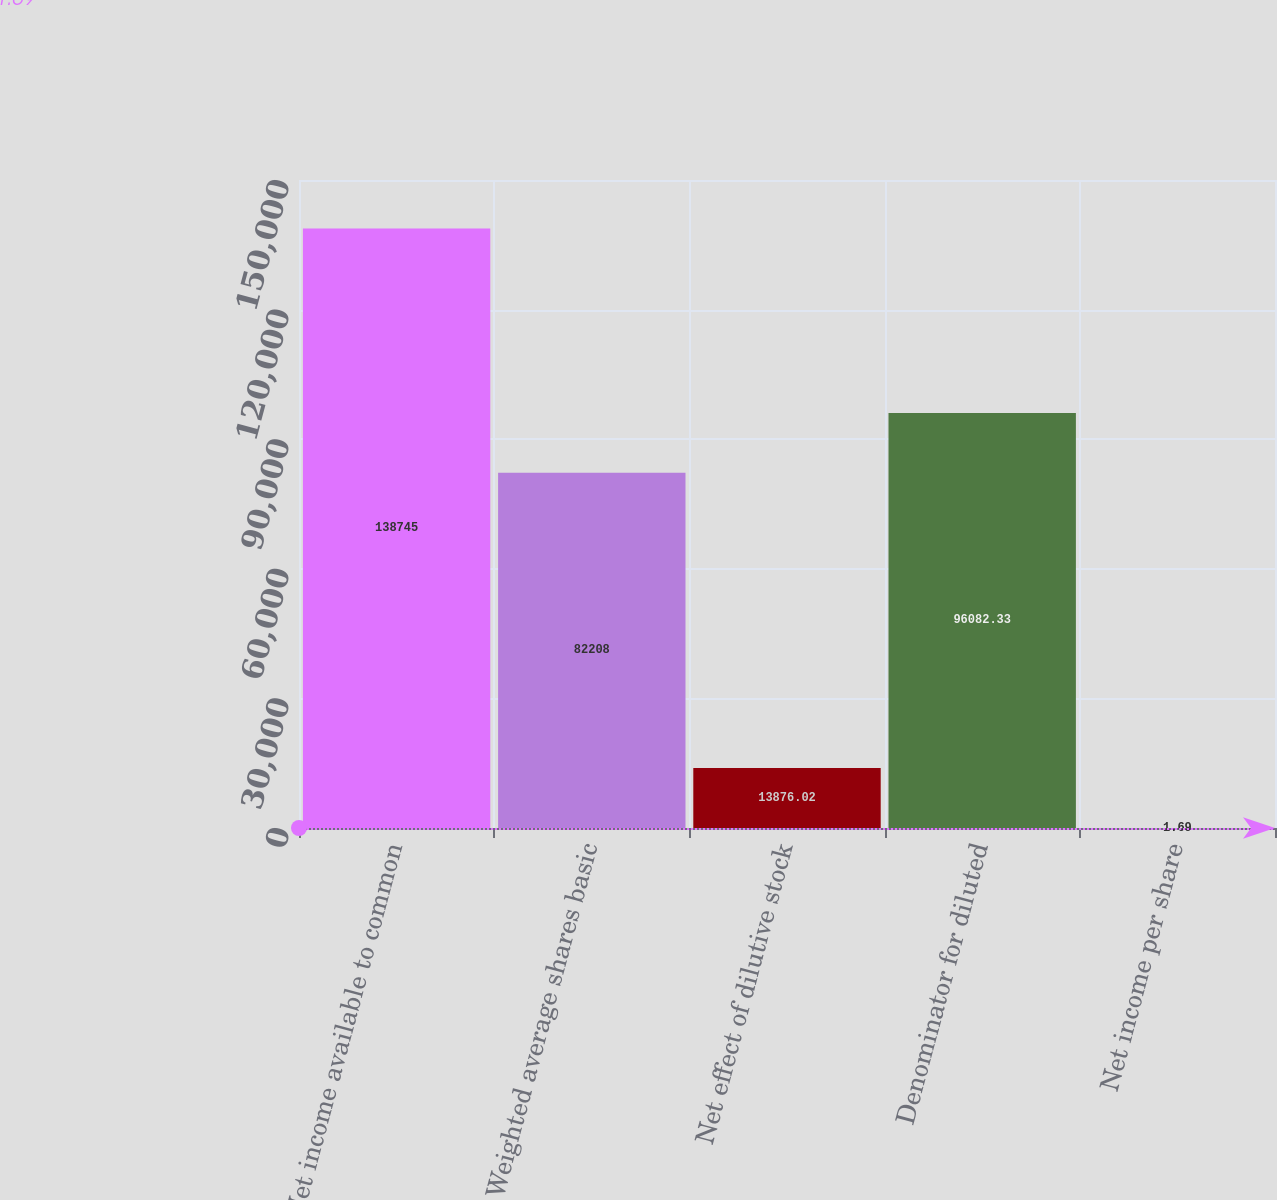Convert chart to OTSL. <chart><loc_0><loc_0><loc_500><loc_500><bar_chart><fcel>Net income available to common<fcel>Weighted average shares basic<fcel>Net effect of dilutive stock<fcel>Denominator for diluted<fcel>Net income per share<nl><fcel>138745<fcel>82208<fcel>13876<fcel>96082.3<fcel>1.69<nl></chart> 